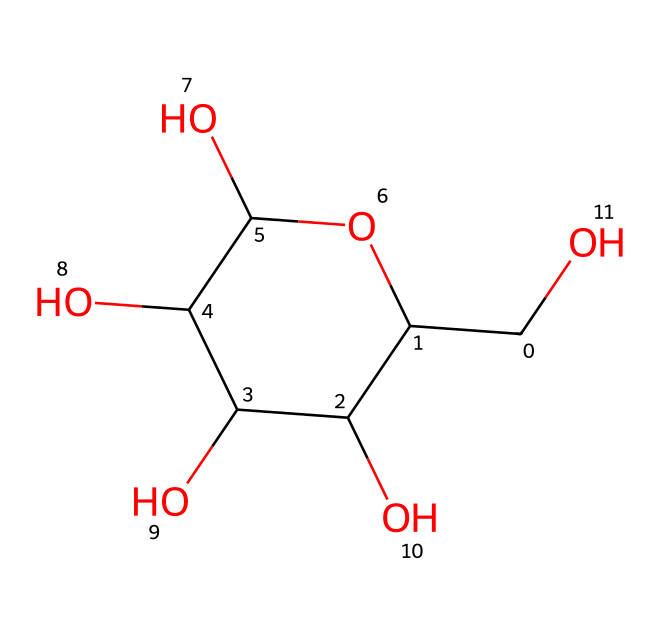What is the molecular formula of glucose? To determine the molecular formula from the SMILES representation, we count the number of each type of atom. In this case, there are 6 carbon (C) atoms, 12 hydrogen (H) atoms, and 6 oxygen (O) atoms, giving the formula C6H12O6.
Answer: C6H12O6 How many hydroxyl groups (-OH) are present in glucose? By analyzing the structure represented in the SMILES, we can count the -OH groups attached to the carbon atoms. Glucose has 5 hydroxyl groups (-OH).
Answer: 5 What type of carbohydrate is glucose classified as? Glucose is classified as a monosaccharide, which is the simplest form of carbohydrate, consisting of a single sugar unit.
Answer: monosaccharide Which type of ring structure does glucose form in solution? Glucose predominantly forms a six-membered ring structure known as a pyranose when it is in solution due to the interactions between the carbon atoms and the hydroxyl groups.
Answer: pyranose How many asymmetric (chiral) centers does glucose have? In the structure of glucose, there are four carbon atoms that are attached to four different groups, making them chiral centers. Therefore, glucose has four asymmetric centers.
Answer: 4 What is the most common form of glucose found in nature? The most common form of glucose found in nature is the alpha-D-glucose form, which is the anomeric form that occurs when the hydroxyl group on the first carbon is in the axial position.
Answer: alpha-D-glucose What role does glucose primarily serve in human metabolism? Glucose primarily serves as the main energy source for human cells, playing a crucial role in cellular respiration and metabolism.
Answer: energy source 